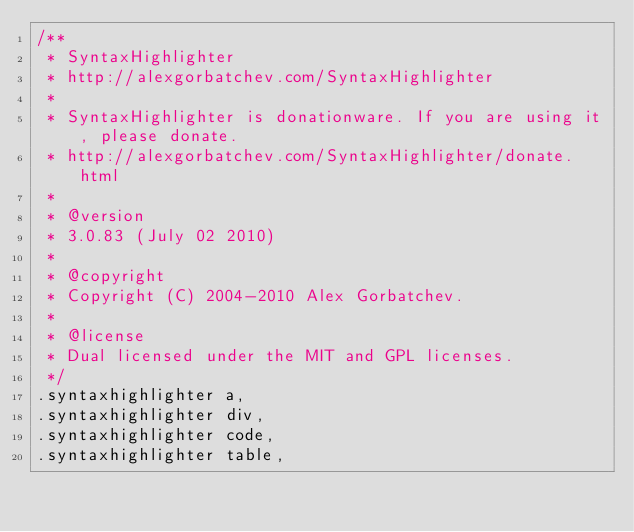<code> <loc_0><loc_0><loc_500><loc_500><_CSS_>/**
 * SyntaxHighlighter
 * http://alexgorbatchev.com/SyntaxHighlighter
 *
 * SyntaxHighlighter is donationware. If you are using it, please donate.
 * http://alexgorbatchev.com/SyntaxHighlighter/donate.html
 *
 * @version
 * 3.0.83 (July 02 2010)
 *
 * @copyright
 * Copyright (C) 2004-2010 Alex Gorbatchev.
 *
 * @license
 * Dual licensed under the MIT and GPL licenses.
 */
.syntaxhighlighter a,
.syntaxhighlighter div,
.syntaxhighlighter code,
.syntaxhighlighter table,</code> 